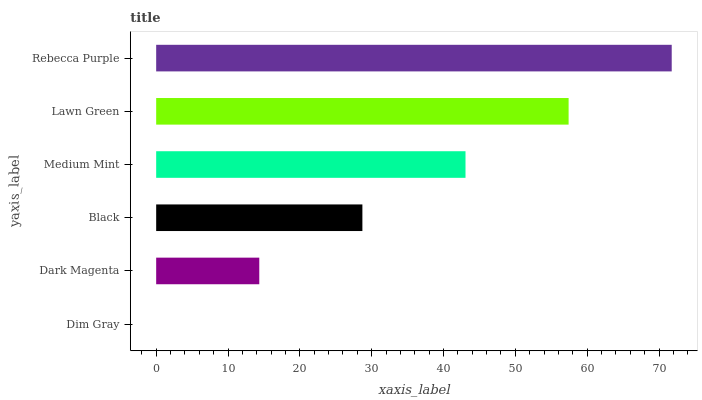Is Dim Gray the minimum?
Answer yes or no. Yes. Is Rebecca Purple the maximum?
Answer yes or no. Yes. Is Dark Magenta the minimum?
Answer yes or no. No. Is Dark Magenta the maximum?
Answer yes or no. No. Is Dark Magenta greater than Dim Gray?
Answer yes or no. Yes. Is Dim Gray less than Dark Magenta?
Answer yes or no. Yes. Is Dim Gray greater than Dark Magenta?
Answer yes or no. No. Is Dark Magenta less than Dim Gray?
Answer yes or no. No. Is Medium Mint the high median?
Answer yes or no. Yes. Is Black the low median?
Answer yes or no. Yes. Is Dim Gray the high median?
Answer yes or no. No. Is Rebecca Purple the low median?
Answer yes or no. No. 